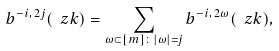Convert formula to latex. <formula><loc_0><loc_0><loc_500><loc_500>b ^ { - i , \, 2 j } ( \ z k ) = \sum _ { \omega \subset [ m ] \colon | \omega | = j } b ^ { - i , \, 2 \omega } ( \ z k ) ,</formula> 